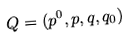<formula> <loc_0><loc_0><loc_500><loc_500>Q = ( p ^ { 0 } , p , q , q _ { 0 } )</formula> 